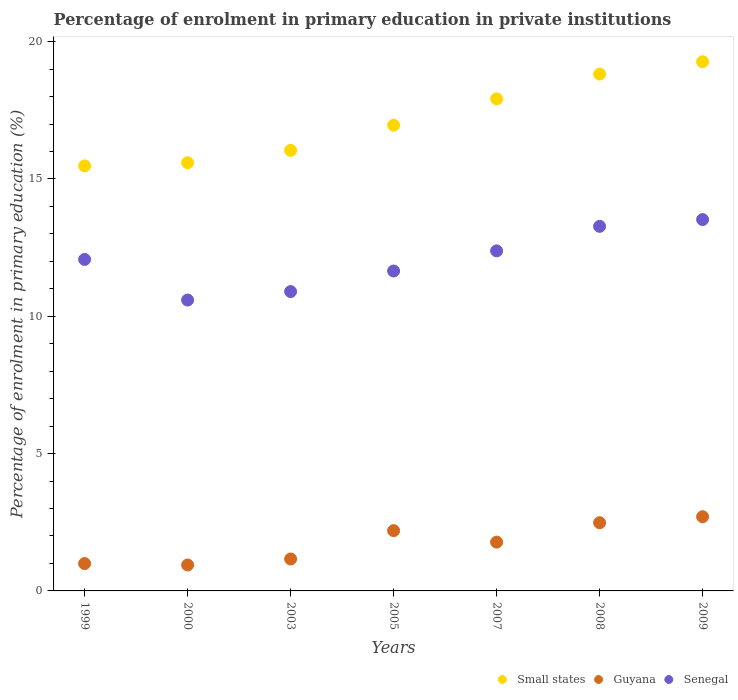Is the number of dotlines equal to the number of legend labels?
Give a very brief answer. Yes. What is the percentage of enrolment in primary education in Small states in 2000?
Offer a terse response. 15.59. Across all years, what is the maximum percentage of enrolment in primary education in Small states?
Your response must be concise. 19.27. Across all years, what is the minimum percentage of enrolment in primary education in Small states?
Make the answer very short. 15.47. In which year was the percentage of enrolment in primary education in Senegal minimum?
Make the answer very short. 2000. What is the total percentage of enrolment in primary education in Small states in the graph?
Your response must be concise. 120.06. What is the difference between the percentage of enrolment in primary education in Small states in 2005 and that in 2009?
Your answer should be compact. -2.31. What is the difference between the percentage of enrolment in primary education in Senegal in 2003 and the percentage of enrolment in primary education in Small states in 2008?
Give a very brief answer. -7.92. What is the average percentage of enrolment in primary education in Small states per year?
Provide a short and direct response. 17.15. In the year 2003, what is the difference between the percentage of enrolment in primary education in Small states and percentage of enrolment in primary education in Guyana?
Provide a succinct answer. 14.88. In how many years, is the percentage of enrolment in primary education in Guyana greater than 9 %?
Your answer should be very brief. 0. What is the ratio of the percentage of enrolment in primary education in Senegal in 2000 to that in 2009?
Provide a succinct answer. 0.78. What is the difference between the highest and the second highest percentage of enrolment in primary education in Small states?
Offer a terse response. 0.45. What is the difference between the highest and the lowest percentage of enrolment in primary education in Guyana?
Your answer should be compact. 1.76. In how many years, is the percentage of enrolment in primary education in Guyana greater than the average percentage of enrolment in primary education in Guyana taken over all years?
Give a very brief answer. 4. Is the sum of the percentage of enrolment in primary education in Senegal in 2003 and 2005 greater than the maximum percentage of enrolment in primary education in Guyana across all years?
Give a very brief answer. Yes. Is the percentage of enrolment in primary education in Guyana strictly greater than the percentage of enrolment in primary education in Senegal over the years?
Provide a succinct answer. No. Is the percentage of enrolment in primary education in Small states strictly less than the percentage of enrolment in primary education in Senegal over the years?
Offer a terse response. No. How many dotlines are there?
Your answer should be very brief. 3. Are the values on the major ticks of Y-axis written in scientific E-notation?
Ensure brevity in your answer.  No. How many legend labels are there?
Your response must be concise. 3. What is the title of the graph?
Keep it short and to the point. Percentage of enrolment in primary education in private institutions. What is the label or title of the X-axis?
Offer a very short reply. Years. What is the label or title of the Y-axis?
Your answer should be compact. Percentage of enrolment in primary education (%). What is the Percentage of enrolment in primary education (%) of Small states in 1999?
Your answer should be very brief. 15.47. What is the Percentage of enrolment in primary education (%) in Guyana in 1999?
Offer a very short reply. 1. What is the Percentage of enrolment in primary education (%) of Senegal in 1999?
Give a very brief answer. 12.07. What is the Percentage of enrolment in primary education (%) in Small states in 2000?
Offer a very short reply. 15.59. What is the Percentage of enrolment in primary education (%) of Guyana in 2000?
Provide a short and direct response. 0.94. What is the Percentage of enrolment in primary education (%) in Senegal in 2000?
Provide a short and direct response. 10.59. What is the Percentage of enrolment in primary education (%) of Small states in 2003?
Provide a succinct answer. 16.04. What is the Percentage of enrolment in primary education (%) of Guyana in 2003?
Provide a short and direct response. 1.16. What is the Percentage of enrolment in primary education (%) in Senegal in 2003?
Keep it short and to the point. 10.9. What is the Percentage of enrolment in primary education (%) of Small states in 2005?
Your answer should be very brief. 16.96. What is the Percentage of enrolment in primary education (%) in Guyana in 2005?
Keep it short and to the point. 2.19. What is the Percentage of enrolment in primary education (%) in Senegal in 2005?
Offer a terse response. 11.65. What is the Percentage of enrolment in primary education (%) of Small states in 2007?
Keep it short and to the point. 17.92. What is the Percentage of enrolment in primary education (%) in Guyana in 2007?
Offer a terse response. 1.78. What is the Percentage of enrolment in primary education (%) of Senegal in 2007?
Make the answer very short. 12.38. What is the Percentage of enrolment in primary education (%) of Small states in 2008?
Your response must be concise. 18.82. What is the Percentage of enrolment in primary education (%) of Guyana in 2008?
Provide a succinct answer. 2.48. What is the Percentage of enrolment in primary education (%) of Senegal in 2008?
Keep it short and to the point. 13.27. What is the Percentage of enrolment in primary education (%) of Small states in 2009?
Offer a very short reply. 19.27. What is the Percentage of enrolment in primary education (%) of Guyana in 2009?
Give a very brief answer. 2.7. What is the Percentage of enrolment in primary education (%) in Senegal in 2009?
Your response must be concise. 13.52. Across all years, what is the maximum Percentage of enrolment in primary education (%) in Small states?
Provide a succinct answer. 19.27. Across all years, what is the maximum Percentage of enrolment in primary education (%) of Guyana?
Ensure brevity in your answer.  2.7. Across all years, what is the maximum Percentage of enrolment in primary education (%) in Senegal?
Provide a succinct answer. 13.52. Across all years, what is the minimum Percentage of enrolment in primary education (%) of Small states?
Your answer should be very brief. 15.47. Across all years, what is the minimum Percentage of enrolment in primary education (%) in Guyana?
Offer a terse response. 0.94. Across all years, what is the minimum Percentage of enrolment in primary education (%) of Senegal?
Provide a succinct answer. 10.59. What is the total Percentage of enrolment in primary education (%) in Small states in the graph?
Your answer should be compact. 120.06. What is the total Percentage of enrolment in primary education (%) of Guyana in the graph?
Ensure brevity in your answer.  12.26. What is the total Percentage of enrolment in primary education (%) of Senegal in the graph?
Your answer should be very brief. 84.38. What is the difference between the Percentage of enrolment in primary education (%) of Small states in 1999 and that in 2000?
Your response must be concise. -0.12. What is the difference between the Percentage of enrolment in primary education (%) of Guyana in 1999 and that in 2000?
Your answer should be compact. 0.05. What is the difference between the Percentage of enrolment in primary education (%) in Senegal in 1999 and that in 2000?
Your answer should be very brief. 1.48. What is the difference between the Percentage of enrolment in primary education (%) in Small states in 1999 and that in 2003?
Your response must be concise. -0.57. What is the difference between the Percentage of enrolment in primary education (%) in Guyana in 1999 and that in 2003?
Provide a short and direct response. -0.17. What is the difference between the Percentage of enrolment in primary education (%) of Senegal in 1999 and that in 2003?
Provide a succinct answer. 1.17. What is the difference between the Percentage of enrolment in primary education (%) of Small states in 1999 and that in 2005?
Offer a very short reply. -1.48. What is the difference between the Percentage of enrolment in primary education (%) in Guyana in 1999 and that in 2005?
Your response must be concise. -1.2. What is the difference between the Percentage of enrolment in primary education (%) of Senegal in 1999 and that in 2005?
Offer a terse response. 0.42. What is the difference between the Percentage of enrolment in primary education (%) in Small states in 1999 and that in 2007?
Your answer should be very brief. -2.44. What is the difference between the Percentage of enrolment in primary education (%) of Guyana in 1999 and that in 2007?
Keep it short and to the point. -0.78. What is the difference between the Percentage of enrolment in primary education (%) in Senegal in 1999 and that in 2007?
Keep it short and to the point. -0.31. What is the difference between the Percentage of enrolment in primary education (%) in Small states in 1999 and that in 2008?
Provide a succinct answer. -3.34. What is the difference between the Percentage of enrolment in primary education (%) of Guyana in 1999 and that in 2008?
Make the answer very short. -1.49. What is the difference between the Percentage of enrolment in primary education (%) in Senegal in 1999 and that in 2008?
Ensure brevity in your answer.  -1.2. What is the difference between the Percentage of enrolment in primary education (%) in Small states in 1999 and that in 2009?
Keep it short and to the point. -3.79. What is the difference between the Percentage of enrolment in primary education (%) in Guyana in 1999 and that in 2009?
Your answer should be very brief. -1.71. What is the difference between the Percentage of enrolment in primary education (%) of Senegal in 1999 and that in 2009?
Your response must be concise. -1.45. What is the difference between the Percentage of enrolment in primary education (%) of Small states in 2000 and that in 2003?
Ensure brevity in your answer.  -0.45. What is the difference between the Percentage of enrolment in primary education (%) of Guyana in 2000 and that in 2003?
Keep it short and to the point. -0.22. What is the difference between the Percentage of enrolment in primary education (%) in Senegal in 2000 and that in 2003?
Keep it short and to the point. -0.31. What is the difference between the Percentage of enrolment in primary education (%) in Small states in 2000 and that in 2005?
Provide a succinct answer. -1.37. What is the difference between the Percentage of enrolment in primary education (%) of Guyana in 2000 and that in 2005?
Ensure brevity in your answer.  -1.25. What is the difference between the Percentage of enrolment in primary education (%) of Senegal in 2000 and that in 2005?
Offer a very short reply. -1.06. What is the difference between the Percentage of enrolment in primary education (%) in Small states in 2000 and that in 2007?
Your answer should be very brief. -2.33. What is the difference between the Percentage of enrolment in primary education (%) of Guyana in 2000 and that in 2007?
Ensure brevity in your answer.  -0.83. What is the difference between the Percentage of enrolment in primary education (%) of Senegal in 2000 and that in 2007?
Provide a short and direct response. -1.79. What is the difference between the Percentage of enrolment in primary education (%) of Small states in 2000 and that in 2008?
Provide a short and direct response. -3.23. What is the difference between the Percentage of enrolment in primary education (%) of Guyana in 2000 and that in 2008?
Offer a terse response. -1.54. What is the difference between the Percentage of enrolment in primary education (%) of Senegal in 2000 and that in 2008?
Your answer should be very brief. -2.68. What is the difference between the Percentage of enrolment in primary education (%) in Small states in 2000 and that in 2009?
Ensure brevity in your answer.  -3.68. What is the difference between the Percentage of enrolment in primary education (%) of Guyana in 2000 and that in 2009?
Your answer should be very brief. -1.76. What is the difference between the Percentage of enrolment in primary education (%) of Senegal in 2000 and that in 2009?
Give a very brief answer. -2.93. What is the difference between the Percentage of enrolment in primary education (%) of Small states in 2003 and that in 2005?
Make the answer very short. -0.92. What is the difference between the Percentage of enrolment in primary education (%) in Guyana in 2003 and that in 2005?
Give a very brief answer. -1.03. What is the difference between the Percentage of enrolment in primary education (%) of Senegal in 2003 and that in 2005?
Give a very brief answer. -0.75. What is the difference between the Percentage of enrolment in primary education (%) in Small states in 2003 and that in 2007?
Offer a very short reply. -1.88. What is the difference between the Percentage of enrolment in primary education (%) in Guyana in 2003 and that in 2007?
Provide a succinct answer. -0.61. What is the difference between the Percentage of enrolment in primary education (%) of Senegal in 2003 and that in 2007?
Give a very brief answer. -1.48. What is the difference between the Percentage of enrolment in primary education (%) of Small states in 2003 and that in 2008?
Provide a short and direct response. -2.78. What is the difference between the Percentage of enrolment in primary education (%) of Guyana in 2003 and that in 2008?
Ensure brevity in your answer.  -1.32. What is the difference between the Percentage of enrolment in primary education (%) in Senegal in 2003 and that in 2008?
Keep it short and to the point. -2.37. What is the difference between the Percentage of enrolment in primary education (%) of Small states in 2003 and that in 2009?
Provide a succinct answer. -3.23. What is the difference between the Percentage of enrolment in primary education (%) in Guyana in 2003 and that in 2009?
Keep it short and to the point. -1.54. What is the difference between the Percentage of enrolment in primary education (%) in Senegal in 2003 and that in 2009?
Your answer should be compact. -2.62. What is the difference between the Percentage of enrolment in primary education (%) of Small states in 2005 and that in 2007?
Ensure brevity in your answer.  -0.96. What is the difference between the Percentage of enrolment in primary education (%) in Guyana in 2005 and that in 2007?
Ensure brevity in your answer.  0.42. What is the difference between the Percentage of enrolment in primary education (%) of Senegal in 2005 and that in 2007?
Offer a terse response. -0.73. What is the difference between the Percentage of enrolment in primary education (%) of Small states in 2005 and that in 2008?
Your answer should be very brief. -1.86. What is the difference between the Percentage of enrolment in primary education (%) in Guyana in 2005 and that in 2008?
Offer a very short reply. -0.29. What is the difference between the Percentage of enrolment in primary education (%) in Senegal in 2005 and that in 2008?
Make the answer very short. -1.63. What is the difference between the Percentage of enrolment in primary education (%) of Small states in 2005 and that in 2009?
Your answer should be very brief. -2.31. What is the difference between the Percentage of enrolment in primary education (%) of Guyana in 2005 and that in 2009?
Provide a succinct answer. -0.51. What is the difference between the Percentage of enrolment in primary education (%) of Senegal in 2005 and that in 2009?
Keep it short and to the point. -1.87. What is the difference between the Percentage of enrolment in primary education (%) in Small states in 2007 and that in 2008?
Give a very brief answer. -0.9. What is the difference between the Percentage of enrolment in primary education (%) in Guyana in 2007 and that in 2008?
Keep it short and to the point. -0.71. What is the difference between the Percentage of enrolment in primary education (%) in Senegal in 2007 and that in 2008?
Provide a succinct answer. -0.89. What is the difference between the Percentage of enrolment in primary education (%) in Small states in 2007 and that in 2009?
Your answer should be very brief. -1.35. What is the difference between the Percentage of enrolment in primary education (%) in Guyana in 2007 and that in 2009?
Your answer should be compact. -0.92. What is the difference between the Percentage of enrolment in primary education (%) of Senegal in 2007 and that in 2009?
Your response must be concise. -1.14. What is the difference between the Percentage of enrolment in primary education (%) in Small states in 2008 and that in 2009?
Offer a terse response. -0.45. What is the difference between the Percentage of enrolment in primary education (%) in Guyana in 2008 and that in 2009?
Offer a terse response. -0.22. What is the difference between the Percentage of enrolment in primary education (%) of Senegal in 2008 and that in 2009?
Ensure brevity in your answer.  -0.25. What is the difference between the Percentage of enrolment in primary education (%) in Small states in 1999 and the Percentage of enrolment in primary education (%) in Guyana in 2000?
Give a very brief answer. 14.53. What is the difference between the Percentage of enrolment in primary education (%) in Small states in 1999 and the Percentage of enrolment in primary education (%) in Senegal in 2000?
Give a very brief answer. 4.88. What is the difference between the Percentage of enrolment in primary education (%) in Guyana in 1999 and the Percentage of enrolment in primary education (%) in Senegal in 2000?
Your response must be concise. -9.59. What is the difference between the Percentage of enrolment in primary education (%) in Small states in 1999 and the Percentage of enrolment in primary education (%) in Guyana in 2003?
Your answer should be very brief. 14.31. What is the difference between the Percentage of enrolment in primary education (%) of Small states in 1999 and the Percentage of enrolment in primary education (%) of Senegal in 2003?
Offer a very short reply. 4.58. What is the difference between the Percentage of enrolment in primary education (%) in Guyana in 1999 and the Percentage of enrolment in primary education (%) in Senegal in 2003?
Offer a terse response. -9.9. What is the difference between the Percentage of enrolment in primary education (%) of Small states in 1999 and the Percentage of enrolment in primary education (%) of Guyana in 2005?
Your response must be concise. 13.28. What is the difference between the Percentage of enrolment in primary education (%) of Small states in 1999 and the Percentage of enrolment in primary education (%) of Senegal in 2005?
Ensure brevity in your answer.  3.83. What is the difference between the Percentage of enrolment in primary education (%) of Guyana in 1999 and the Percentage of enrolment in primary education (%) of Senegal in 2005?
Give a very brief answer. -10.65. What is the difference between the Percentage of enrolment in primary education (%) in Small states in 1999 and the Percentage of enrolment in primary education (%) in Guyana in 2007?
Ensure brevity in your answer.  13.7. What is the difference between the Percentage of enrolment in primary education (%) in Small states in 1999 and the Percentage of enrolment in primary education (%) in Senegal in 2007?
Provide a succinct answer. 3.09. What is the difference between the Percentage of enrolment in primary education (%) of Guyana in 1999 and the Percentage of enrolment in primary education (%) of Senegal in 2007?
Offer a terse response. -11.38. What is the difference between the Percentage of enrolment in primary education (%) of Small states in 1999 and the Percentage of enrolment in primary education (%) of Guyana in 2008?
Make the answer very short. 12.99. What is the difference between the Percentage of enrolment in primary education (%) of Small states in 1999 and the Percentage of enrolment in primary education (%) of Senegal in 2008?
Offer a very short reply. 2.2. What is the difference between the Percentage of enrolment in primary education (%) in Guyana in 1999 and the Percentage of enrolment in primary education (%) in Senegal in 2008?
Give a very brief answer. -12.28. What is the difference between the Percentage of enrolment in primary education (%) of Small states in 1999 and the Percentage of enrolment in primary education (%) of Guyana in 2009?
Give a very brief answer. 12.77. What is the difference between the Percentage of enrolment in primary education (%) of Small states in 1999 and the Percentage of enrolment in primary education (%) of Senegal in 2009?
Give a very brief answer. 1.95. What is the difference between the Percentage of enrolment in primary education (%) in Guyana in 1999 and the Percentage of enrolment in primary education (%) in Senegal in 2009?
Your response must be concise. -12.52. What is the difference between the Percentage of enrolment in primary education (%) of Small states in 2000 and the Percentage of enrolment in primary education (%) of Guyana in 2003?
Your answer should be compact. 14.43. What is the difference between the Percentage of enrolment in primary education (%) in Small states in 2000 and the Percentage of enrolment in primary education (%) in Senegal in 2003?
Offer a very short reply. 4.69. What is the difference between the Percentage of enrolment in primary education (%) of Guyana in 2000 and the Percentage of enrolment in primary education (%) of Senegal in 2003?
Offer a terse response. -9.95. What is the difference between the Percentage of enrolment in primary education (%) of Small states in 2000 and the Percentage of enrolment in primary education (%) of Guyana in 2005?
Make the answer very short. 13.4. What is the difference between the Percentage of enrolment in primary education (%) in Small states in 2000 and the Percentage of enrolment in primary education (%) in Senegal in 2005?
Keep it short and to the point. 3.94. What is the difference between the Percentage of enrolment in primary education (%) in Guyana in 2000 and the Percentage of enrolment in primary education (%) in Senegal in 2005?
Ensure brevity in your answer.  -10.7. What is the difference between the Percentage of enrolment in primary education (%) in Small states in 2000 and the Percentage of enrolment in primary education (%) in Guyana in 2007?
Your answer should be very brief. 13.81. What is the difference between the Percentage of enrolment in primary education (%) of Small states in 2000 and the Percentage of enrolment in primary education (%) of Senegal in 2007?
Your answer should be compact. 3.21. What is the difference between the Percentage of enrolment in primary education (%) of Guyana in 2000 and the Percentage of enrolment in primary education (%) of Senegal in 2007?
Offer a terse response. -11.44. What is the difference between the Percentage of enrolment in primary education (%) in Small states in 2000 and the Percentage of enrolment in primary education (%) in Guyana in 2008?
Give a very brief answer. 13.11. What is the difference between the Percentage of enrolment in primary education (%) of Small states in 2000 and the Percentage of enrolment in primary education (%) of Senegal in 2008?
Offer a terse response. 2.32. What is the difference between the Percentage of enrolment in primary education (%) in Guyana in 2000 and the Percentage of enrolment in primary education (%) in Senegal in 2008?
Offer a terse response. -12.33. What is the difference between the Percentage of enrolment in primary education (%) of Small states in 2000 and the Percentage of enrolment in primary education (%) of Guyana in 2009?
Offer a terse response. 12.89. What is the difference between the Percentage of enrolment in primary education (%) of Small states in 2000 and the Percentage of enrolment in primary education (%) of Senegal in 2009?
Make the answer very short. 2.07. What is the difference between the Percentage of enrolment in primary education (%) in Guyana in 2000 and the Percentage of enrolment in primary education (%) in Senegal in 2009?
Make the answer very short. -12.58. What is the difference between the Percentage of enrolment in primary education (%) of Small states in 2003 and the Percentage of enrolment in primary education (%) of Guyana in 2005?
Your response must be concise. 13.85. What is the difference between the Percentage of enrolment in primary education (%) of Small states in 2003 and the Percentage of enrolment in primary education (%) of Senegal in 2005?
Your answer should be very brief. 4.39. What is the difference between the Percentage of enrolment in primary education (%) of Guyana in 2003 and the Percentage of enrolment in primary education (%) of Senegal in 2005?
Keep it short and to the point. -10.49. What is the difference between the Percentage of enrolment in primary education (%) in Small states in 2003 and the Percentage of enrolment in primary education (%) in Guyana in 2007?
Make the answer very short. 14.26. What is the difference between the Percentage of enrolment in primary education (%) of Small states in 2003 and the Percentage of enrolment in primary education (%) of Senegal in 2007?
Provide a short and direct response. 3.66. What is the difference between the Percentage of enrolment in primary education (%) of Guyana in 2003 and the Percentage of enrolment in primary education (%) of Senegal in 2007?
Give a very brief answer. -11.22. What is the difference between the Percentage of enrolment in primary education (%) of Small states in 2003 and the Percentage of enrolment in primary education (%) of Guyana in 2008?
Provide a short and direct response. 13.56. What is the difference between the Percentage of enrolment in primary education (%) of Small states in 2003 and the Percentage of enrolment in primary education (%) of Senegal in 2008?
Your response must be concise. 2.77. What is the difference between the Percentage of enrolment in primary education (%) of Guyana in 2003 and the Percentage of enrolment in primary education (%) of Senegal in 2008?
Provide a succinct answer. -12.11. What is the difference between the Percentage of enrolment in primary education (%) in Small states in 2003 and the Percentage of enrolment in primary education (%) in Guyana in 2009?
Make the answer very short. 13.34. What is the difference between the Percentage of enrolment in primary education (%) in Small states in 2003 and the Percentage of enrolment in primary education (%) in Senegal in 2009?
Keep it short and to the point. 2.52. What is the difference between the Percentage of enrolment in primary education (%) of Guyana in 2003 and the Percentage of enrolment in primary education (%) of Senegal in 2009?
Your answer should be compact. -12.36. What is the difference between the Percentage of enrolment in primary education (%) in Small states in 2005 and the Percentage of enrolment in primary education (%) in Guyana in 2007?
Your response must be concise. 15.18. What is the difference between the Percentage of enrolment in primary education (%) of Small states in 2005 and the Percentage of enrolment in primary education (%) of Senegal in 2007?
Ensure brevity in your answer.  4.58. What is the difference between the Percentage of enrolment in primary education (%) of Guyana in 2005 and the Percentage of enrolment in primary education (%) of Senegal in 2007?
Provide a succinct answer. -10.19. What is the difference between the Percentage of enrolment in primary education (%) of Small states in 2005 and the Percentage of enrolment in primary education (%) of Guyana in 2008?
Your answer should be compact. 14.47. What is the difference between the Percentage of enrolment in primary education (%) of Small states in 2005 and the Percentage of enrolment in primary education (%) of Senegal in 2008?
Your response must be concise. 3.68. What is the difference between the Percentage of enrolment in primary education (%) of Guyana in 2005 and the Percentage of enrolment in primary education (%) of Senegal in 2008?
Offer a terse response. -11.08. What is the difference between the Percentage of enrolment in primary education (%) of Small states in 2005 and the Percentage of enrolment in primary education (%) of Guyana in 2009?
Keep it short and to the point. 14.26. What is the difference between the Percentage of enrolment in primary education (%) in Small states in 2005 and the Percentage of enrolment in primary education (%) in Senegal in 2009?
Your answer should be very brief. 3.44. What is the difference between the Percentage of enrolment in primary education (%) of Guyana in 2005 and the Percentage of enrolment in primary education (%) of Senegal in 2009?
Offer a very short reply. -11.33. What is the difference between the Percentage of enrolment in primary education (%) of Small states in 2007 and the Percentage of enrolment in primary education (%) of Guyana in 2008?
Provide a succinct answer. 15.43. What is the difference between the Percentage of enrolment in primary education (%) in Small states in 2007 and the Percentage of enrolment in primary education (%) in Senegal in 2008?
Provide a succinct answer. 4.64. What is the difference between the Percentage of enrolment in primary education (%) of Guyana in 2007 and the Percentage of enrolment in primary education (%) of Senegal in 2008?
Give a very brief answer. -11.5. What is the difference between the Percentage of enrolment in primary education (%) in Small states in 2007 and the Percentage of enrolment in primary education (%) in Guyana in 2009?
Offer a very short reply. 15.22. What is the difference between the Percentage of enrolment in primary education (%) in Small states in 2007 and the Percentage of enrolment in primary education (%) in Senegal in 2009?
Provide a succinct answer. 4.4. What is the difference between the Percentage of enrolment in primary education (%) in Guyana in 2007 and the Percentage of enrolment in primary education (%) in Senegal in 2009?
Offer a very short reply. -11.74. What is the difference between the Percentage of enrolment in primary education (%) in Small states in 2008 and the Percentage of enrolment in primary education (%) in Guyana in 2009?
Your answer should be compact. 16.12. What is the difference between the Percentage of enrolment in primary education (%) in Small states in 2008 and the Percentage of enrolment in primary education (%) in Senegal in 2009?
Provide a short and direct response. 5.3. What is the difference between the Percentage of enrolment in primary education (%) in Guyana in 2008 and the Percentage of enrolment in primary education (%) in Senegal in 2009?
Make the answer very short. -11.04. What is the average Percentage of enrolment in primary education (%) of Small states per year?
Keep it short and to the point. 17.15. What is the average Percentage of enrolment in primary education (%) of Guyana per year?
Give a very brief answer. 1.75. What is the average Percentage of enrolment in primary education (%) of Senegal per year?
Provide a succinct answer. 12.05. In the year 1999, what is the difference between the Percentage of enrolment in primary education (%) of Small states and Percentage of enrolment in primary education (%) of Guyana?
Your answer should be very brief. 14.48. In the year 1999, what is the difference between the Percentage of enrolment in primary education (%) in Small states and Percentage of enrolment in primary education (%) in Senegal?
Your response must be concise. 3.41. In the year 1999, what is the difference between the Percentage of enrolment in primary education (%) of Guyana and Percentage of enrolment in primary education (%) of Senegal?
Provide a short and direct response. -11.07. In the year 2000, what is the difference between the Percentage of enrolment in primary education (%) in Small states and Percentage of enrolment in primary education (%) in Guyana?
Your answer should be very brief. 14.65. In the year 2000, what is the difference between the Percentage of enrolment in primary education (%) in Guyana and Percentage of enrolment in primary education (%) in Senegal?
Your answer should be very brief. -9.65. In the year 2003, what is the difference between the Percentage of enrolment in primary education (%) in Small states and Percentage of enrolment in primary education (%) in Guyana?
Give a very brief answer. 14.88. In the year 2003, what is the difference between the Percentage of enrolment in primary education (%) in Small states and Percentage of enrolment in primary education (%) in Senegal?
Your answer should be very brief. 5.14. In the year 2003, what is the difference between the Percentage of enrolment in primary education (%) of Guyana and Percentage of enrolment in primary education (%) of Senegal?
Offer a terse response. -9.74. In the year 2005, what is the difference between the Percentage of enrolment in primary education (%) of Small states and Percentage of enrolment in primary education (%) of Guyana?
Your answer should be very brief. 14.76. In the year 2005, what is the difference between the Percentage of enrolment in primary education (%) in Small states and Percentage of enrolment in primary education (%) in Senegal?
Your answer should be very brief. 5.31. In the year 2005, what is the difference between the Percentage of enrolment in primary education (%) in Guyana and Percentage of enrolment in primary education (%) in Senegal?
Offer a very short reply. -9.45. In the year 2007, what is the difference between the Percentage of enrolment in primary education (%) of Small states and Percentage of enrolment in primary education (%) of Guyana?
Keep it short and to the point. 16.14. In the year 2007, what is the difference between the Percentage of enrolment in primary education (%) in Small states and Percentage of enrolment in primary education (%) in Senegal?
Keep it short and to the point. 5.54. In the year 2007, what is the difference between the Percentage of enrolment in primary education (%) in Guyana and Percentage of enrolment in primary education (%) in Senegal?
Ensure brevity in your answer.  -10.6. In the year 2008, what is the difference between the Percentage of enrolment in primary education (%) in Small states and Percentage of enrolment in primary education (%) in Guyana?
Make the answer very short. 16.33. In the year 2008, what is the difference between the Percentage of enrolment in primary education (%) in Small states and Percentage of enrolment in primary education (%) in Senegal?
Provide a succinct answer. 5.54. In the year 2008, what is the difference between the Percentage of enrolment in primary education (%) of Guyana and Percentage of enrolment in primary education (%) of Senegal?
Your response must be concise. -10.79. In the year 2009, what is the difference between the Percentage of enrolment in primary education (%) of Small states and Percentage of enrolment in primary education (%) of Guyana?
Ensure brevity in your answer.  16.57. In the year 2009, what is the difference between the Percentage of enrolment in primary education (%) in Small states and Percentage of enrolment in primary education (%) in Senegal?
Provide a short and direct response. 5.75. In the year 2009, what is the difference between the Percentage of enrolment in primary education (%) in Guyana and Percentage of enrolment in primary education (%) in Senegal?
Offer a very short reply. -10.82. What is the ratio of the Percentage of enrolment in primary education (%) of Small states in 1999 to that in 2000?
Make the answer very short. 0.99. What is the ratio of the Percentage of enrolment in primary education (%) in Guyana in 1999 to that in 2000?
Your response must be concise. 1.05. What is the ratio of the Percentage of enrolment in primary education (%) in Senegal in 1999 to that in 2000?
Your response must be concise. 1.14. What is the ratio of the Percentage of enrolment in primary education (%) of Small states in 1999 to that in 2003?
Offer a very short reply. 0.96. What is the ratio of the Percentage of enrolment in primary education (%) in Guyana in 1999 to that in 2003?
Offer a very short reply. 0.86. What is the ratio of the Percentage of enrolment in primary education (%) in Senegal in 1999 to that in 2003?
Make the answer very short. 1.11. What is the ratio of the Percentage of enrolment in primary education (%) in Small states in 1999 to that in 2005?
Give a very brief answer. 0.91. What is the ratio of the Percentage of enrolment in primary education (%) in Guyana in 1999 to that in 2005?
Your response must be concise. 0.45. What is the ratio of the Percentage of enrolment in primary education (%) of Senegal in 1999 to that in 2005?
Make the answer very short. 1.04. What is the ratio of the Percentage of enrolment in primary education (%) of Small states in 1999 to that in 2007?
Give a very brief answer. 0.86. What is the ratio of the Percentage of enrolment in primary education (%) in Guyana in 1999 to that in 2007?
Ensure brevity in your answer.  0.56. What is the ratio of the Percentage of enrolment in primary education (%) of Senegal in 1999 to that in 2007?
Ensure brevity in your answer.  0.97. What is the ratio of the Percentage of enrolment in primary education (%) of Small states in 1999 to that in 2008?
Your response must be concise. 0.82. What is the ratio of the Percentage of enrolment in primary education (%) of Guyana in 1999 to that in 2008?
Keep it short and to the point. 0.4. What is the ratio of the Percentage of enrolment in primary education (%) of Senegal in 1999 to that in 2008?
Ensure brevity in your answer.  0.91. What is the ratio of the Percentage of enrolment in primary education (%) of Small states in 1999 to that in 2009?
Make the answer very short. 0.8. What is the ratio of the Percentage of enrolment in primary education (%) of Guyana in 1999 to that in 2009?
Provide a succinct answer. 0.37. What is the ratio of the Percentage of enrolment in primary education (%) of Senegal in 1999 to that in 2009?
Your answer should be very brief. 0.89. What is the ratio of the Percentage of enrolment in primary education (%) in Small states in 2000 to that in 2003?
Keep it short and to the point. 0.97. What is the ratio of the Percentage of enrolment in primary education (%) of Guyana in 2000 to that in 2003?
Keep it short and to the point. 0.81. What is the ratio of the Percentage of enrolment in primary education (%) in Senegal in 2000 to that in 2003?
Offer a terse response. 0.97. What is the ratio of the Percentage of enrolment in primary education (%) in Small states in 2000 to that in 2005?
Offer a very short reply. 0.92. What is the ratio of the Percentage of enrolment in primary education (%) in Guyana in 2000 to that in 2005?
Provide a succinct answer. 0.43. What is the ratio of the Percentage of enrolment in primary education (%) in Senegal in 2000 to that in 2005?
Provide a short and direct response. 0.91. What is the ratio of the Percentage of enrolment in primary education (%) of Small states in 2000 to that in 2007?
Offer a terse response. 0.87. What is the ratio of the Percentage of enrolment in primary education (%) of Guyana in 2000 to that in 2007?
Your answer should be compact. 0.53. What is the ratio of the Percentage of enrolment in primary education (%) of Senegal in 2000 to that in 2007?
Your response must be concise. 0.86. What is the ratio of the Percentage of enrolment in primary education (%) of Small states in 2000 to that in 2008?
Provide a succinct answer. 0.83. What is the ratio of the Percentage of enrolment in primary education (%) of Guyana in 2000 to that in 2008?
Provide a short and direct response. 0.38. What is the ratio of the Percentage of enrolment in primary education (%) of Senegal in 2000 to that in 2008?
Offer a terse response. 0.8. What is the ratio of the Percentage of enrolment in primary education (%) of Small states in 2000 to that in 2009?
Provide a succinct answer. 0.81. What is the ratio of the Percentage of enrolment in primary education (%) of Guyana in 2000 to that in 2009?
Keep it short and to the point. 0.35. What is the ratio of the Percentage of enrolment in primary education (%) of Senegal in 2000 to that in 2009?
Provide a short and direct response. 0.78. What is the ratio of the Percentage of enrolment in primary education (%) in Small states in 2003 to that in 2005?
Ensure brevity in your answer.  0.95. What is the ratio of the Percentage of enrolment in primary education (%) in Guyana in 2003 to that in 2005?
Provide a succinct answer. 0.53. What is the ratio of the Percentage of enrolment in primary education (%) in Senegal in 2003 to that in 2005?
Offer a very short reply. 0.94. What is the ratio of the Percentage of enrolment in primary education (%) of Small states in 2003 to that in 2007?
Offer a very short reply. 0.9. What is the ratio of the Percentage of enrolment in primary education (%) in Guyana in 2003 to that in 2007?
Provide a succinct answer. 0.65. What is the ratio of the Percentage of enrolment in primary education (%) of Senegal in 2003 to that in 2007?
Ensure brevity in your answer.  0.88. What is the ratio of the Percentage of enrolment in primary education (%) of Small states in 2003 to that in 2008?
Your answer should be very brief. 0.85. What is the ratio of the Percentage of enrolment in primary education (%) in Guyana in 2003 to that in 2008?
Offer a terse response. 0.47. What is the ratio of the Percentage of enrolment in primary education (%) of Senegal in 2003 to that in 2008?
Give a very brief answer. 0.82. What is the ratio of the Percentage of enrolment in primary education (%) of Small states in 2003 to that in 2009?
Give a very brief answer. 0.83. What is the ratio of the Percentage of enrolment in primary education (%) of Guyana in 2003 to that in 2009?
Provide a succinct answer. 0.43. What is the ratio of the Percentage of enrolment in primary education (%) in Senegal in 2003 to that in 2009?
Your answer should be compact. 0.81. What is the ratio of the Percentage of enrolment in primary education (%) of Small states in 2005 to that in 2007?
Offer a very short reply. 0.95. What is the ratio of the Percentage of enrolment in primary education (%) in Guyana in 2005 to that in 2007?
Make the answer very short. 1.24. What is the ratio of the Percentage of enrolment in primary education (%) in Senegal in 2005 to that in 2007?
Your response must be concise. 0.94. What is the ratio of the Percentage of enrolment in primary education (%) of Small states in 2005 to that in 2008?
Your answer should be very brief. 0.9. What is the ratio of the Percentage of enrolment in primary education (%) of Guyana in 2005 to that in 2008?
Your answer should be very brief. 0.88. What is the ratio of the Percentage of enrolment in primary education (%) in Senegal in 2005 to that in 2008?
Offer a very short reply. 0.88. What is the ratio of the Percentage of enrolment in primary education (%) of Small states in 2005 to that in 2009?
Provide a short and direct response. 0.88. What is the ratio of the Percentage of enrolment in primary education (%) in Guyana in 2005 to that in 2009?
Offer a very short reply. 0.81. What is the ratio of the Percentage of enrolment in primary education (%) of Senegal in 2005 to that in 2009?
Ensure brevity in your answer.  0.86. What is the ratio of the Percentage of enrolment in primary education (%) in Small states in 2007 to that in 2008?
Offer a very short reply. 0.95. What is the ratio of the Percentage of enrolment in primary education (%) of Guyana in 2007 to that in 2008?
Keep it short and to the point. 0.72. What is the ratio of the Percentage of enrolment in primary education (%) in Senegal in 2007 to that in 2008?
Your response must be concise. 0.93. What is the ratio of the Percentage of enrolment in primary education (%) of Small states in 2007 to that in 2009?
Provide a succinct answer. 0.93. What is the ratio of the Percentage of enrolment in primary education (%) in Guyana in 2007 to that in 2009?
Provide a succinct answer. 0.66. What is the ratio of the Percentage of enrolment in primary education (%) of Senegal in 2007 to that in 2009?
Offer a terse response. 0.92. What is the ratio of the Percentage of enrolment in primary education (%) of Small states in 2008 to that in 2009?
Make the answer very short. 0.98. What is the ratio of the Percentage of enrolment in primary education (%) in Guyana in 2008 to that in 2009?
Give a very brief answer. 0.92. What is the ratio of the Percentage of enrolment in primary education (%) of Senegal in 2008 to that in 2009?
Your response must be concise. 0.98. What is the difference between the highest and the second highest Percentage of enrolment in primary education (%) of Small states?
Give a very brief answer. 0.45. What is the difference between the highest and the second highest Percentage of enrolment in primary education (%) of Guyana?
Provide a short and direct response. 0.22. What is the difference between the highest and the second highest Percentage of enrolment in primary education (%) in Senegal?
Offer a terse response. 0.25. What is the difference between the highest and the lowest Percentage of enrolment in primary education (%) in Small states?
Ensure brevity in your answer.  3.79. What is the difference between the highest and the lowest Percentage of enrolment in primary education (%) of Guyana?
Your response must be concise. 1.76. What is the difference between the highest and the lowest Percentage of enrolment in primary education (%) in Senegal?
Provide a short and direct response. 2.93. 